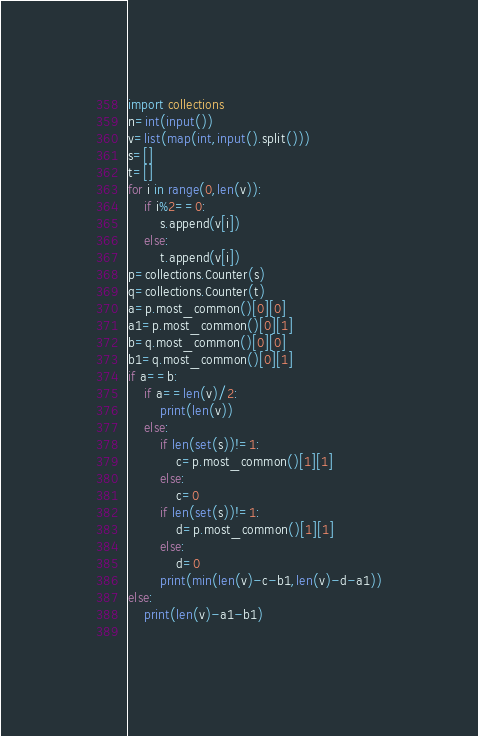Convert code to text. <code><loc_0><loc_0><loc_500><loc_500><_Python_>import collections
n=int(input())
v=list(map(int,input().split()))
s=[]
t=[]
for i in range(0,len(v)):
    if i%2==0:
        s.append(v[i])
    else:
        t.append(v[i])
p=collections.Counter(s)
q=collections.Counter(t)
a=p.most_common()[0][0]
a1=p.most_common()[0][1]
b=q.most_common()[0][0]
b1=q.most_common()[0][1]
if a==b:
    if a==len(v)/2:
        print(len(v))
    else:
        if len(set(s))!=1:
            c=p.most_common()[1][1]
        else:
            c=0
        if len(set(s))!=1:
            d=p.most_common()[1][1]
        else:
            d=0
        print(min(len(v)-c-b1,len(v)-d-a1))
else:
    print(len(v)-a1-b1)
        </code> 